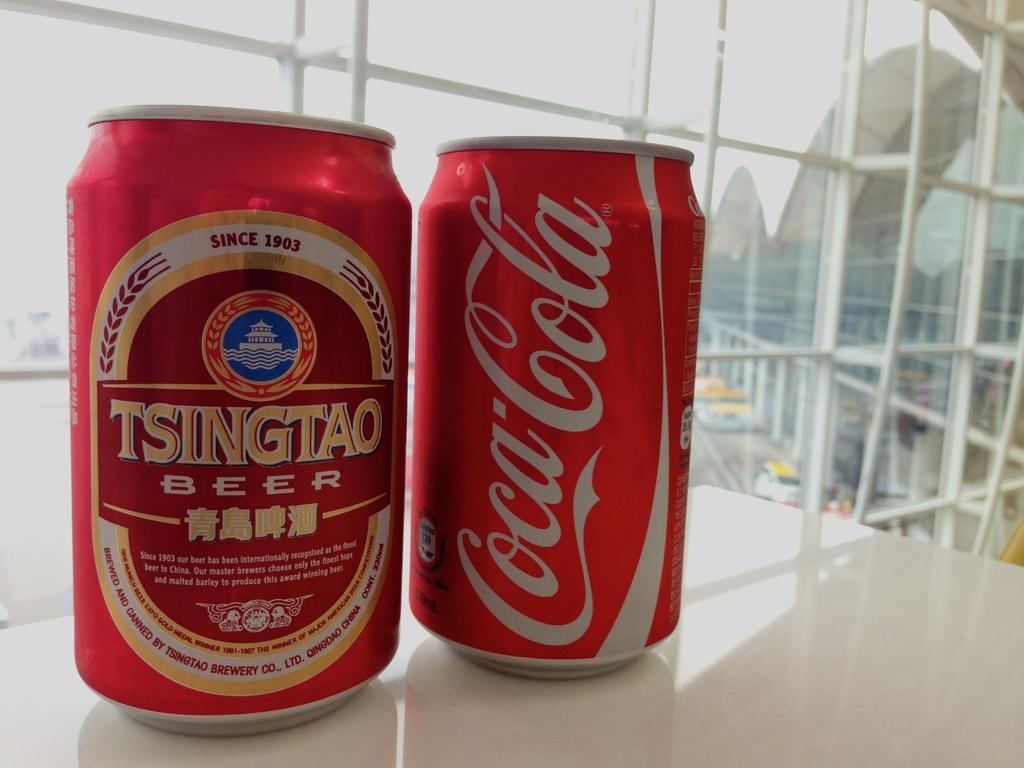Describe this image in one or two sentences. In this image I can see a white colored surface and on it I can see two cars which are red in color. In the background I can see the glass windows through which I can see the building and the sky. 